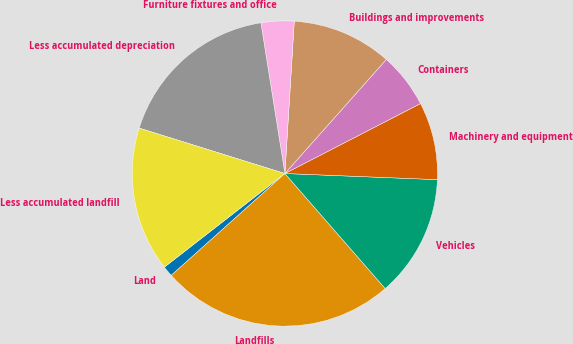Convert chart. <chart><loc_0><loc_0><loc_500><loc_500><pie_chart><fcel>Land<fcel>Landfills<fcel>Vehicles<fcel>Machinery and equipment<fcel>Containers<fcel>Buildings and improvements<fcel>Furniture fixtures and office<fcel>Less accumulated depreciation<fcel>Less accumulated landfill<nl><fcel>1.12%<fcel>24.78%<fcel>12.95%<fcel>8.22%<fcel>5.85%<fcel>10.59%<fcel>3.49%<fcel>17.68%<fcel>15.32%<nl></chart> 